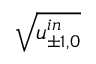Convert formula to latex. <formula><loc_0><loc_0><loc_500><loc_500>\sqrt { u _ { \pm 1 , 0 } ^ { i n } }</formula> 